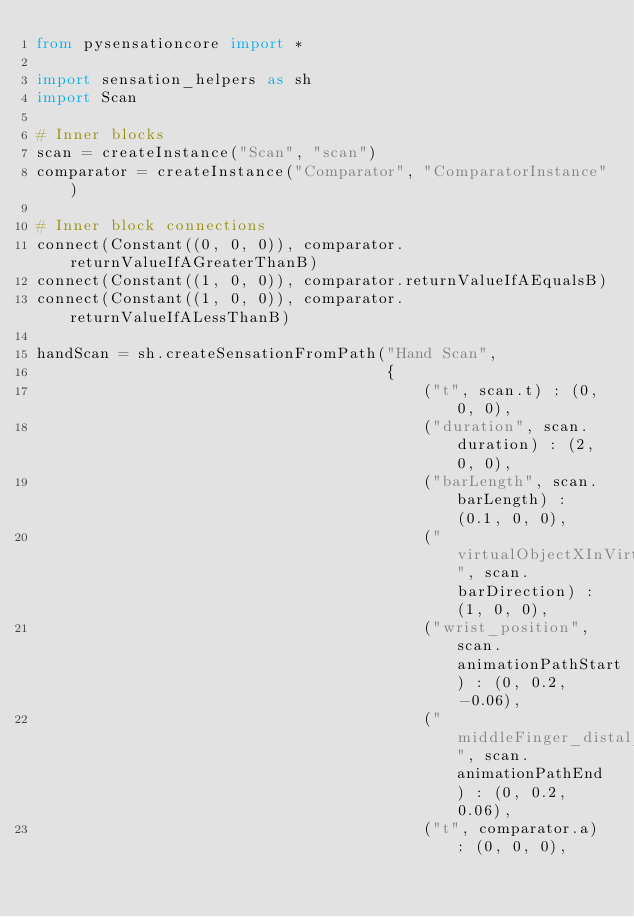Convert code to text. <code><loc_0><loc_0><loc_500><loc_500><_Python_>from pysensationcore import *

import sensation_helpers as sh
import Scan

# Inner blocks
scan = createInstance("Scan", "scan")
comparator = createInstance("Comparator", "ComparatorInstance")

# Inner block connections
connect(Constant((0, 0, 0)), comparator.returnValueIfAGreaterThanB)
connect(Constant((1, 0, 0)), comparator.returnValueIfAEqualsB)
connect(Constant((1, 0, 0)), comparator.returnValueIfALessThanB)

handScan = sh.createSensationFromPath("Hand Scan",
                                      {
                                          ("t", scan.t) : (0, 0, 0),
                                          ("duration", scan.duration) : (2, 0, 0),
                                          ("barLength", scan.barLength) : (0.1, 0, 0),
                                          ("virtualObjectXInVirtualSpace", scan.barDirection) : (1, 0, 0),
                                          ("wrist_position", scan.animationPathStart) : (0, 0.2, -0.06),
                                          ("middleFinger_distal_position", scan.animationPathEnd) : (0, 0.2, 0.06),
                                          ("t", comparator.a) : (0, 0, 0),</code> 